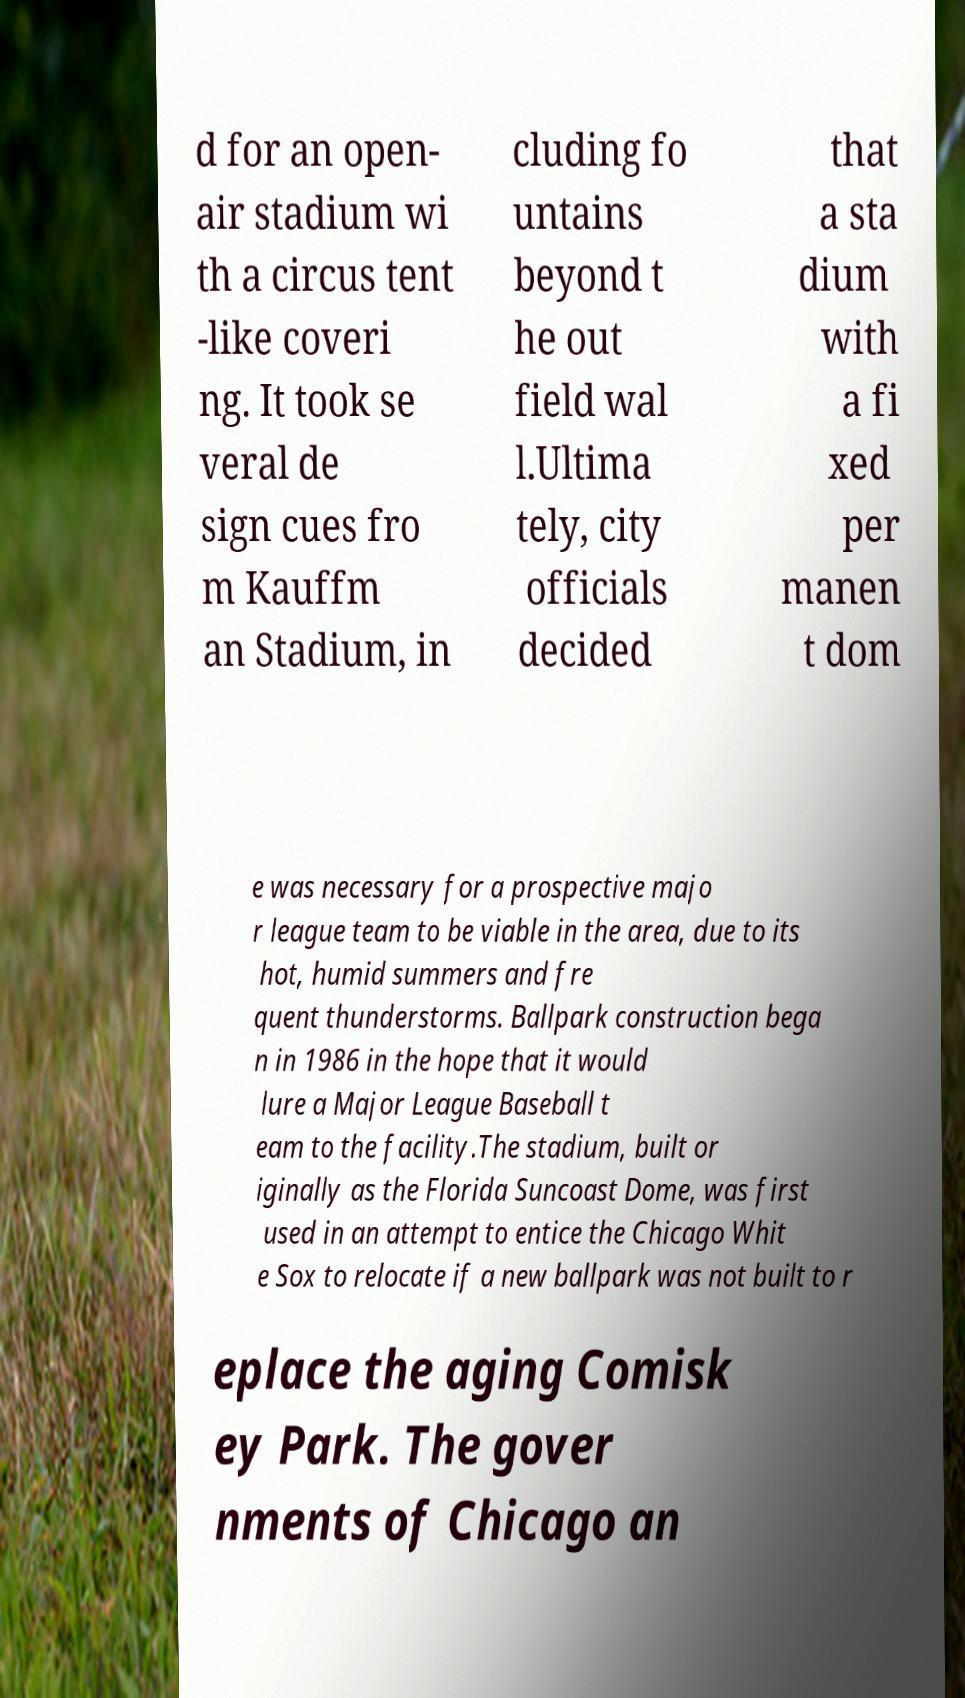Please read and relay the text visible in this image. What does it say? d for an open- air stadium wi th a circus tent -like coveri ng. It took se veral de sign cues fro m Kauffm an Stadium, in cluding fo untains beyond t he out field wal l.Ultima tely, city officials decided that a sta dium with a fi xed per manen t dom e was necessary for a prospective majo r league team to be viable in the area, due to its hot, humid summers and fre quent thunderstorms. Ballpark construction bega n in 1986 in the hope that it would lure a Major League Baseball t eam to the facility.The stadium, built or iginally as the Florida Suncoast Dome, was first used in an attempt to entice the Chicago Whit e Sox to relocate if a new ballpark was not built to r eplace the aging Comisk ey Park. The gover nments of Chicago an 